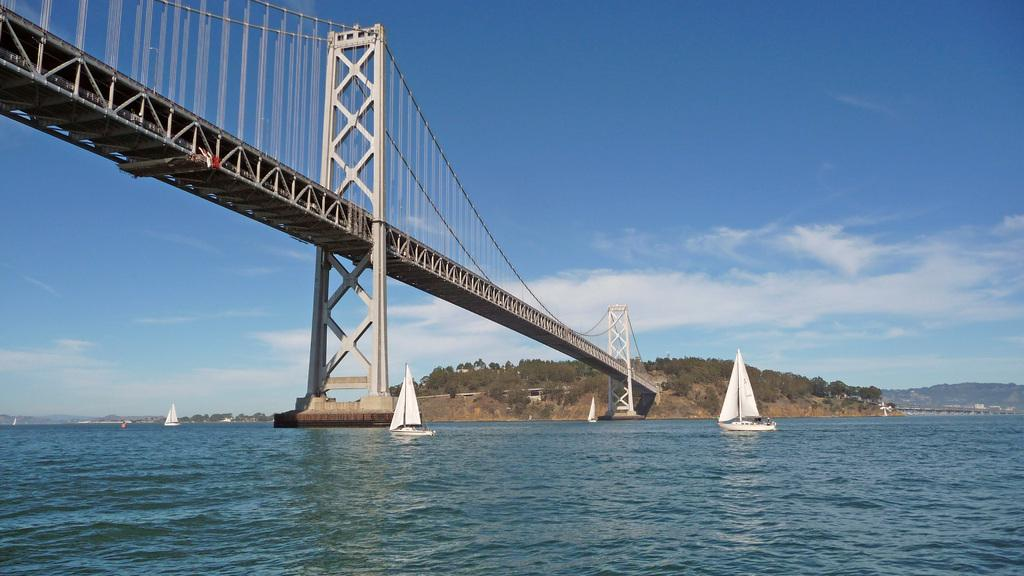What type of vehicles can be seen on the water in the image? There are boats on the water in the image. What type of structure is present in the image? There is a bridge in the image. What type of vegetation can be seen in the image? There are trees in the image. What is visible in the background of the image? The sky is visible in the background of the image. What can be seen in the sky in the image? Clouds are present in the sky. What type of acoustics can be heard from the boats in the image? There is no information about the acoustics of the boats in the image, as it only provides visual information. Can you tell me how many cars are visible in the image? There are no cars present in the image; it features boats, a bridge, trees, and a sky with clouds. 